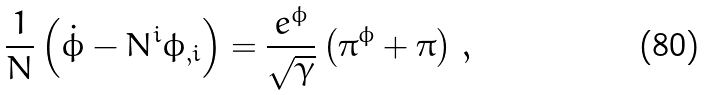Convert formula to latex. <formula><loc_0><loc_0><loc_500><loc_500>\frac { 1 } { N } \left ( \dot { \phi } - N ^ { i } \phi _ { , i } \right ) = \frac { e ^ { \phi } } { \sqrt { \gamma } } \left ( \pi ^ { \phi } + \pi \right ) \, ,</formula> 